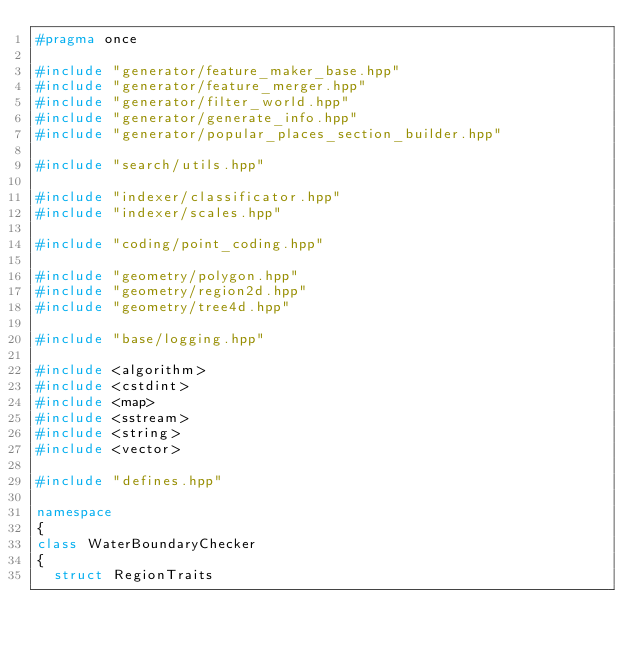<code> <loc_0><loc_0><loc_500><loc_500><_C++_>#pragma once

#include "generator/feature_maker_base.hpp"
#include "generator/feature_merger.hpp"
#include "generator/filter_world.hpp"
#include "generator/generate_info.hpp"
#include "generator/popular_places_section_builder.hpp"

#include "search/utils.hpp"

#include "indexer/classificator.hpp"
#include "indexer/scales.hpp"

#include "coding/point_coding.hpp"

#include "geometry/polygon.hpp"
#include "geometry/region2d.hpp"
#include "geometry/tree4d.hpp"

#include "base/logging.hpp"

#include <algorithm>
#include <cstdint>
#include <map>
#include <sstream>
#include <string>
#include <vector>

#include "defines.hpp"

namespace
{
class WaterBoundaryChecker
{
  struct RegionTraits</code> 